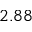<formula> <loc_0><loc_0><loc_500><loc_500>2 . 8 8</formula> 